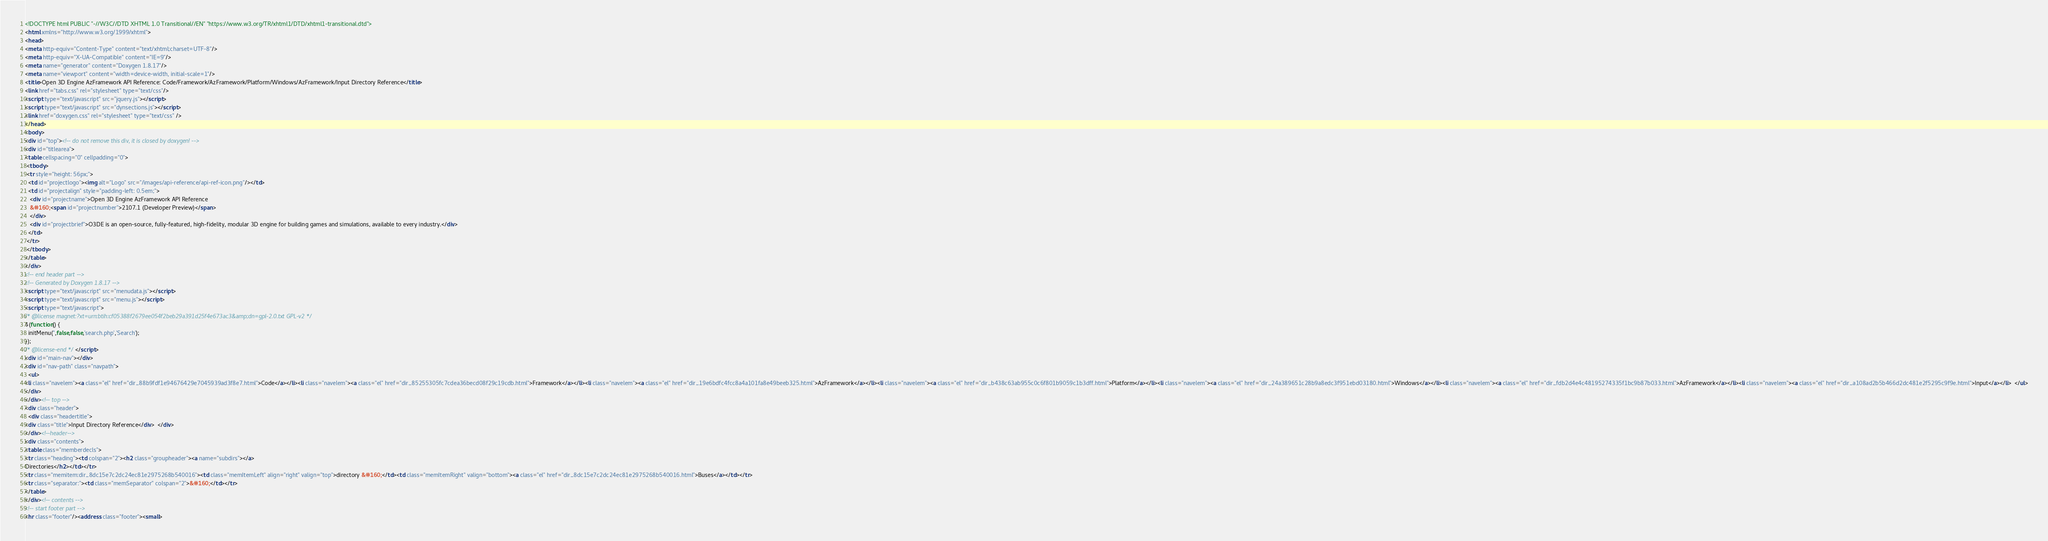Convert code to text. <code><loc_0><loc_0><loc_500><loc_500><_HTML_><!DOCTYPE html PUBLIC "-//W3C//DTD XHTML 1.0 Transitional//EN" "https://www.w3.org/TR/xhtml1/DTD/xhtml1-transitional.dtd">
<html xmlns="http://www.w3.org/1999/xhtml">
<head>
<meta http-equiv="Content-Type" content="text/xhtml;charset=UTF-8"/>
<meta http-equiv="X-UA-Compatible" content="IE=9"/>
<meta name="generator" content="Doxygen 1.8.17"/>
<meta name="viewport" content="width=device-width, initial-scale=1"/>
<title>Open 3D Engine AzFramework API Reference: Code/Framework/AzFramework/Platform/Windows/AzFramework/Input Directory Reference</title>
<link href="tabs.css" rel="stylesheet" type="text/css"/>
<script type="text/javascript" src="jquery.js"></script>
<script type="text/javascript" src="dynsections.js"></script>
<link href="doxygen.css" rel="stylesheet" type="text/css" />
</head>
<body>
<div id="top"><!-- do not remove this div, it is closed by doxygen! -->
<div id="titlearea">
<table cellspacing="0" cellpadding="0">
 <tbody>
 <tr style="height: 56px;">
  <td id="projectlogo"><img alt="Logo" src="/images/api-reference/api-ref-icon.png"/></td>
  <td id="projectalign" style="padding-left: 0.5em;">
   <div id="projectname">Open 3D Engine AzFramework API Reference
   &#160;<span id="projectnumber">2107.1 (Developer Preview)</span>
   </div>
   <div id="projectbrief">O3DE is an open-source, fully-featured, high-fidelity, modular 3D engine for building games and simulations, available to every industry.</div>
  </td>
 </tr>
 </tbody>
</table>
</div>
<!-- end header part -->
<!-- Generated by Doxygen 1.8.17 -->
<script type="text/javascript" src="menudata.js"></script>
<script type="text/javascript" src="menu.js"></script>
<script type="text/javascript">
/* @license magnet:?xt=urn:btih:cf05388f2679ee054f2beb29a391d25f4e673ac3&amp;dn=gpl-2.0.txt GPL-v2 */
$(function() {
  initMenu('',false,false,'search.php','Search');
});
/* @license-end */</script>
<div id="main-nav"></div>
<div id="nav-path" class="navpath">
  <ul>
<li class="navelem"><a class="el" href="dir_88b9fdf1e94676429e7045939ad3f8e7.html">Code</a></li><li class="navelem"><a class="el" href="dir_85255305fc7cdea36becd08f29c19cdb.html">Framework</a></li><li class="navelem"><a class="el" href="dir_19e6bdfc4fcc8a4a101fa8e49beeb325.html">AzFramework</a></li><li class="navelem"><a class="el" href="dir_b438c63ab955c0c6f801b9059c1b3dff.html">Platform</a></li><li class="navelem"><a class="el" href="dir_24a389651c28b9a8edc3f951ebd03180.html">Windows</a></li><li class="navelem"><a class="el" href="dir_fdb2d4e4c48195274335f1bc9b87b033.html">AzFramework</a></li><li class="navelem"><a class="el" href="dir_a108ad2b5b466d2dc481e2f5295c9f9e.html">Input</a></li>  </ul>
</div>
</div><!-- top -->
<div class="header">
  <div class="headertitle">
<div class="title">Input Directory Reference</div>  </div>
</div><!--header-->
<div class="contents">
<table class="memberdecls">
<tr class="heading"><td colspan="2"><h2 class="groupheader"><a name="subdirs"></a>
Directories</h2></td></tr>
<tr class="memitem:dir_8dc15e7c2dc24ec81e2975268b540016"><td class="memItemLeft" align="right" valign="top">directory &#160;</td><td class="memItemRight" valign="bottom"><a class="el" href="dir_8dc15e7c2dc24ec81e2975268b540016.html">Buses</a></td></tr>
<tr class="separator:"><td class="memSeparator" colspan="2">&#160;</td></tr>
</table>
</div><!-- contents -->
<!-- start footer part -->
<hr class="footer"/><address class="footer"><small></code> 